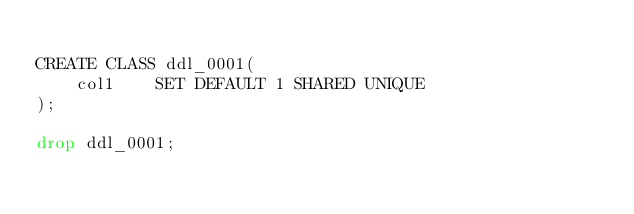Convert code to text. <code><loc_0><loc_0><loc_500><loc_500><_SQL_>
CREATE CLASS ddl_0001(
    col1    SET DEFAULT 1 SHARED UNIQUE
);

drop ddl_0001;
</code> 